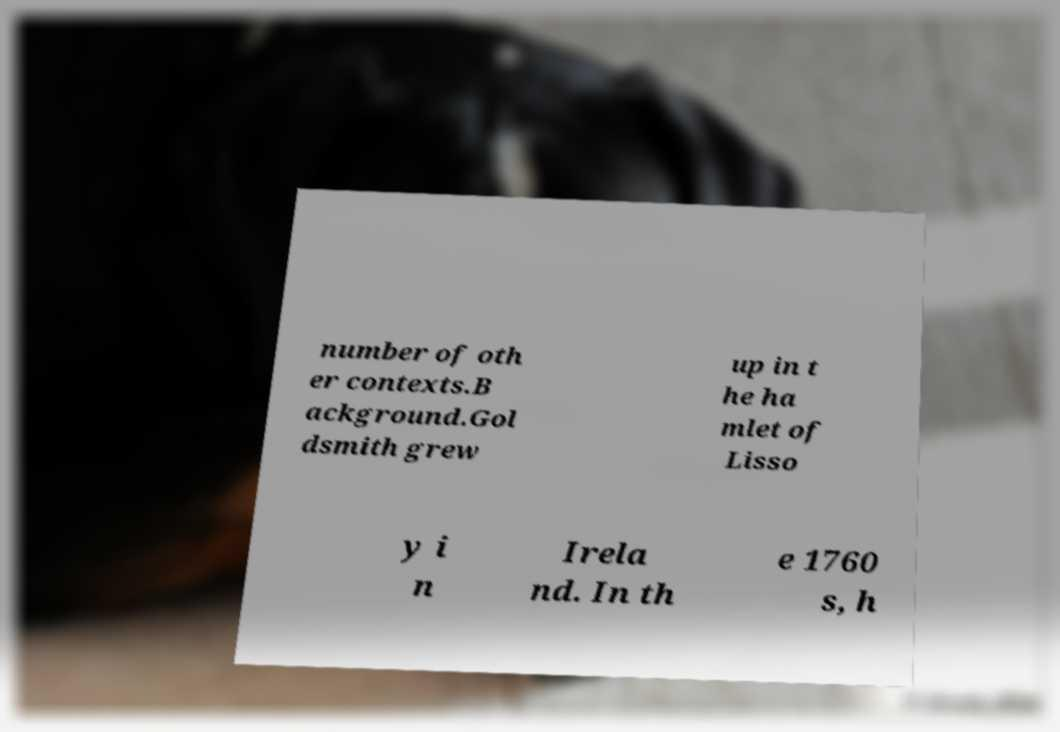There's text embedded in this image that I need extracted. Can you transcribe it verbatim? number of oth er contexts.B ackground.Gol dsmith grew up in t he ha mlet of Lisso y i n Irela nd. In th e 1760 s, h 